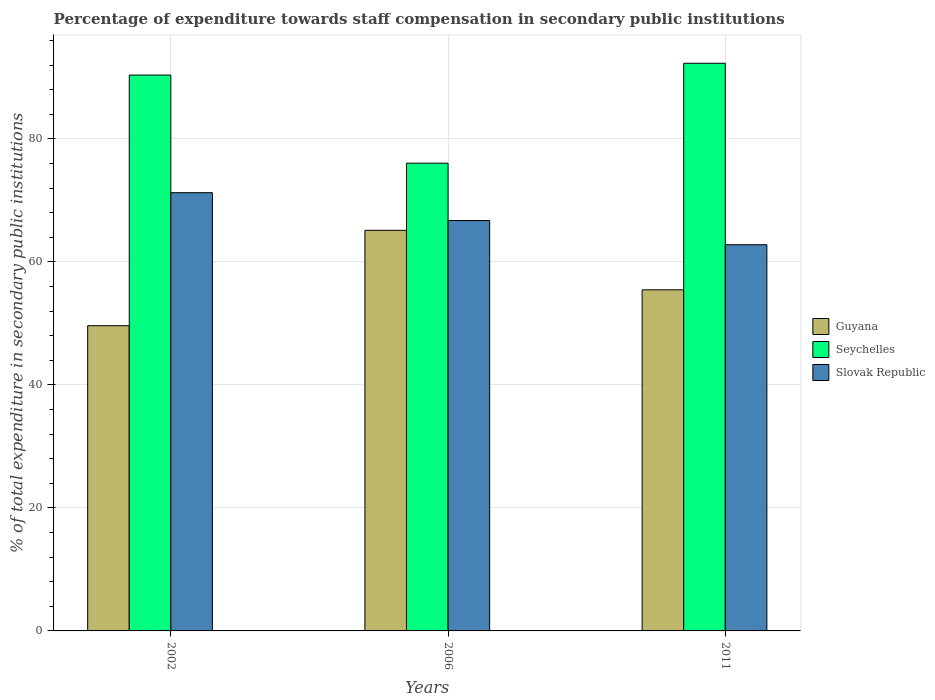How many groups of bars are there?
Provide a succinct answer. 3. Are the number of bars on each tick of the X-axis equal?
Give a very brief answer. Yes. In how many cases, is the number of bars for a given year not equal to the number of legend labels?
Provide a succinct answer. 0. What is the percentage of expenditure towards staff compensation in Guyana in 2011?
Your answer should be very brief. 55.46. Across all years, what is the maximum percentage of expenditure towards staff compensation in Seychelles?
Your answer should be compact. 92.3. Across all years, what is the minimum percentage of expenditure towards staff compensation in Guyana?
Provide a succinct answer. 49.63. In which year was the percentage of expenditure towards staff compensation in Guyana maximum?
Provide a succinct answer. 2006. In which year was the percentage of expenditure towards staff compensation in Slovak Republic minimum?
Your answer should be compact. 2011. What is the total percentage of expenditure towards staff compensation in Guyana in the graph?
Your response must be concise. 170.23. What is the difference between the percentage of expenditure towards staff compensation in Slovak Republic in 2006 and that in 2011?
Ensure brevity in your answer.  3.93. What is the difference between the percentage of expenditure towards staff compensation in Guyana in 2011 and the percentage of expenditure towards staff compensation in Slovak Republic in 2006?
Offer a terse response. -11.27. What is the average percentage of expenditure towards staff compensation in Seychelles per year?
Your answer should be compact. 86.25. In the year 2006, what is the difference between the percentage of expenditure towards staff compensation in Guyana and percentage of expenditure towards staff compensation in Seychelles?
Your response must be concise. -10.92. In how many years, is the percentage of expenditure towards staff compensation in Slovak Republic greater than 84 %?
Ensure brevity in your answer.  0. What is the ratio of the percentage of expenditure towards staff compensation in Slovak Republic in 2002 to that in 2006?
Your answer should be very brief. 1.07. Is the difference between the percentage of expenditure towards staff compensation in Guyana in 2006 and 2011 greater than the difference between the percentage of expenditure towards staff compensation in Seychelles in 2006 and 2011?
Make the answer very short. Yes. What is the difference between the highest and the second highest percentage of expenditure towards staff compensation in Slovak Republic?
Provide a succinct answer. 4.53. What is the difference between the highest and the lowest percentage of expenditure towards staff compensation in Seychelles?
Offer a very short reply. 16.25. Is the sum of the percentage of expenditure towards staff compensation in Guyana in 2006 and 2011 greater than the maximum percentage of expenditure towards staff compensation in Seychelles across all years?
Keep it short and to the point. Yes. What does the 3rd bar from the left in 2002 represents?
Your answer should be very brief. Slovak Republic. What does the 2nd bar from the right in 2002 represents?
Your answer should be very brief. Seychelles. Is it the case that in every year, the sum of the percentage of expenditure towards staff compensation in Slovak Republic and percentage of expenditure towards staff compensation in Seychelles is greater than the percentage of expenditure towards staff compensation in Guyana?
Your answer should be compact. Yes. How many bars are there?
Make the answer very short. 9. How many years are there in the graph?
Keep it short and to the point. 3. Does the graph contain grids?
Your answer should be very brief. Yes. Where does the legend appear in the graph?
Ensure brevity in your answer.  Center right. How many legend labels are there?
Offer a very short reply. 3. What is the title of the graph?
Provide a short and direct response. Percentage of expenditure towards staff compensation in secondary public institutions. Does "Argentina" appear as one of the legend labels in the graph?
Offer a very short reply. No. What is the label or title of the Y-axis?
Keep it short and to the point. % of total expenditure in secondary public institutions. What is the % of total expenditure in secondary public institutions of Guyana in 2002?
Ensure brevity in your answer.  49.63. What is the % of total expenditure in secondary public institutions in Seychelles in 2002?
Give a very brief answer. 90.38. What is the % of total expenditure in secondary public institutions in Slovak Republic in 2002?
Provide a short and direct response. 71.26. What is the % of total expenditure in secondary public institutions of Guyana in 2006?
Ensure brevity in your answer.  65.13. What is the % of total expenditure in secondary public institutions in Seychelles in 2006?
Make the answer very short. 76.06. What is the % of total expenditure in secondary public institutions of Slovak Republic in 2006?
Keep it short and to the point. 66.73. What is the % of total expenditure in secondary public institutions in Guyana in 2011?
Offer a terse response. 55.46. What is the % of total expenditure in secondary public institutions in Seychelles in 2011?
Provide a short and direct response. 92.3. What is the % of total expenditure in secondary public institutions of Slovak Republic in 2011?
Your answer should be compact. 62.8. Across all years, what is the maximum % of total expenditure in secondary public institutions in Guyana?
Your response must be concise. 65.13. Across all years, what is the maximum % of total expenditure in secondary public institutions of Seychelles?
Ensure brevity in your answer.  92.3. Across all years, what is the maximum % of total expenditure in secondary public institutions of Slovak Republic?
Your answer should be very brief. 71.26. Across all years, what is the minimum % of total expenditure in secondary public institutions of Guyana?
Your answer should be very brief. 49.63. Across all years, what is the minimum % of total expenditure in secondary public institutions of Seychelles?
Your answer should be very brief. 76.06. Across all years, what is the minimum % of total expenditure in secondary public institutions in Slovak Republic?
Your answer should be compact. 62.8. What is the total % of total expenditure in secondary public institutions in Guyana in the graph?
Offer a very short reply. 170.23. What is the total % of total expenditure in secondary public institutions of Seychelles in the graph?
Ensure brevity in your answer.  258.74. What is the total % of total expenditure in secondary public institutions in Slovak Republic in the graph?
Provide a short and direct response. 200.78. What is the difference between the % of total expenditure in secondary public institutions of Guyana in 2002 and that in 2006?
Provide a short and direct response. -15.5. What is the difference between the % of total expenditure in secondary public institutions of Seychelles in 2002 and that in 2006?
Make the answer very short. 14.33. What is the difference between the % of total expenditure in secondary public institutions in Slovak Republic in 2002 and that in 2006?
Your answer should be very brief. 4.53. What is the difference between the % of total expenditure in secondary public institutions in Guyana in 2002 and that in 2011?
Make the answer very short. -5.83. What is the difference between the % of total expenditure in secondary public institutions in Seychelles in 2002 and that in 2011?
Provide a succinct answer. -1.92. What is the difference between the % of total expenditure in secondary public institutions of Slovak Republic in 2002 and that in 2011?
Offer a terse response. 8.46. What is the difference between the % of total expenditure in secondary public institutions in Guyana in 2006 and that in 2011?
Your response must be concise. 9.67. What is the difference between the % of total expenditure in secondary public institutions in Seychelles in 2006 and that in 2011?
Your answer should be very brief. -16.25. What is the difference between the % of total expenditure in secondary public institutions in Slovak Republic in 2006 and that in 2011?
Keep it short and to the point. 3.93. What is the difference between the % of total expenditure in secondary public institutions of Guyana in 2002 and the % of total expenditure in secondary public institutions of Seychelles in 2006?
Keep it short and to the point. -26.43. What is the difference between the % of total expenditure in secondary public institutions of Guyana in 2002 and the % of total expenditure in secondary public institutions of Slovak Republic in 2006?
Provide a succinct answer. -17.1. What is the difference between the % of total expenditure in secondary public institutions of Seychelles in 2002 and the % of total expenditure in secondary public institutions of Slovak Republic in 2006?
Your response must be concise. 23.65. What is the difference between the % of total expenditure in secondary public institutions in Guyana in 2002 and the % of total expenditure in secondary public institutions in Seychelles in 2011?
Offer a very short reply. -42.67. What is the difference between the % of total expenditure in secondary public institutions in Guyana in 2002 and the % of total expenditure in secondary public institutions in Slovak Republic in 2011?
Keep it short and to the point. -13.17. What is the difference between the % of total expenditure in secondary public institutions in Seychelles in 2002 and the % of total expenditure in secondary public institutions in Slovak Republic in 2011?
Make the answer very short. 27.58. What is the difference between the % of total expenditure in secondary public institutions in Guyana in 2006 and the % of total expenditure in secondary public institutions in Seychelles in 2011?
Give a very brief answer. -27.17. What is the difference between the % of total expenditure in secondary public institutions in Guyana in 2006 and the % of total expenditure in secondary public institutions in Slovak Republic in 2011?
Ensure brevity in your answer.  2.34. What is the difference between the % of total expenditure in secondary public institutions of Seychelles in 2006 and the % of total expenditure in secondary public institutions of Slovak Republic in 2011?
Offer a very short reply. 13.26. What is the average % of total expenditure in secondary public institutions in Guyana per year?
Your answer should be compact. 56.74. What is the average % of total expenditure in secondary public institutions in Seychelles per year?
Offer a terse response. 86.25. What is the average % of total expenditure in secondary public institutions of Slovak Republic per year?
Your answer should be very brief. 66.93. In the year 2002, what is the difference between the % of total expenditure in secondary public institutions of Guyana and % of total expenditure in secondary public institutions of Seychelles?
Ensure brevity in your answer.  -40.75. In the year 2002, what is the difference between the % of total expenditure in secondary public institutions in Guyana and % of total expenditure in secondary public institutions in Slovak Republic?
Offer a terse response. -21.63. In the year 2002, what is the difference between the % of total expenditure in secondary public institutions of Seychelles and % of total expenditure in secondary public institutions of Slovak Republic?
Your response must be concise. 19.12. In the year 2006, what is the difference between the % of total expenditure in secondary public institutions in Guyana and % of total expenditure in secondary public institutions in Seychelles?
Your answer should be compact. -10.92. In the year 2006, what is the difference between the % of total expenditure in secondary public institutions of Guyana and % of total expenditure in secondary public institutions of Slovak Republic?
Make the answer very short. -1.6. In the year 2006, what is the difference between the % of total expenditure in secondary public institutions in Seychelles and % of total expenditure in secondary public institutions in Slovak Republic?
Keep it short and to the point. 9.33. In the year 2011, what is the difference between the % of total expenditure in secondary public institutions of Guyana and % of total expenditure in secondary public institutions of Seychelles?
Offer a terse response. -36.84. In the year 2011, what is the difference between the % of total expenditure in secondary public institutions in Guyana and % of total expenditure in secondary public institutions in Slovak Republic?
Provide a succinct answer. -7.34. In the year 2011, what is the difference between the % of total expenditure in secondary public institutions in Seychelles and % of total expenditure in secondary public institutions in Slovak Republic?
Keep it short and to the point. 29.5. What is the ratio of the % of total expenditure in secondary public institutions in Guyana in 2002 to that in 2006?
Your answer should be compact. 0.76. What is the ratio of the % of total expenditure in secondary public institutions in Seychelles in 2002 to that in 2006?
Provide a short and direct response. 1.19. What is the ratio of the % of total expenditure in secondary public institutions of Slovak Republic in 2002 to that in 2006?
Give a very brief answer. 1.07. What is the ratio of the % of total expenditure in secondary public institutions of Guyana in 2002 to that in 2011?
Your response must be concise. 0.89. What is the ratio of the % of total expenditure in secondary public institutions in Seychelles in 2002 to that in 2011?
Ensure brevity in your answer.  0.98. What is the ratio of the % of total expenditure in secondary public institutions of Slovak Republic in 2002 to that in 2011?
Your answer should be very brief. 1.13. What is the ratio of the % of total expenditure in secondary public institutions of Guyana in 2006 to that in 2011?
Offer a very short reply. 1.17. What is the ratio of the % of total expenditure in secondary public institutions in Seychelles in 2006 to that in 2011?
Give a very brief answer. 0.82. What is the ratio of the % of total expenditure in secondary public institutions in Slovak Republic in 2006 to that in 2011?
Give a very brief answer. 1.06. What is the difference between the highest and the second highest % of total expenditure in secondary public institutions of Guyana?
Make the answer very short. 9.67. What is the difference between the highest and the second highest % of total expenditure in secondary public institutions in Seychelles?
Provide a short and direct response. 1.92. What is the difference between the highest and the second highest % of total expenditure in secondary public institutions in Slovak Republic?
Your answer should be compact. 4.53. What is the difference between the highest and the lowest % of total expenditure in secondary public institutions of Guyana?
Your answer should be very brief. 15.5. What is the difference between the highest and the lowest % of total expenditure in secondary public institutions of Seychelles?
Ensure brevity in your answer.  16.25. What is the difference between the highest and the lowest % of total expenditure in secondary public institutions in Slovak Republic?
Provide a succinct answer. 8.46. 